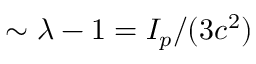<formula> <loc_0><loc_0><loc_500><loc_500>\sim \lambda - 1 = I _ { p } / ( 3 c ^ { 2 } )</formula> 